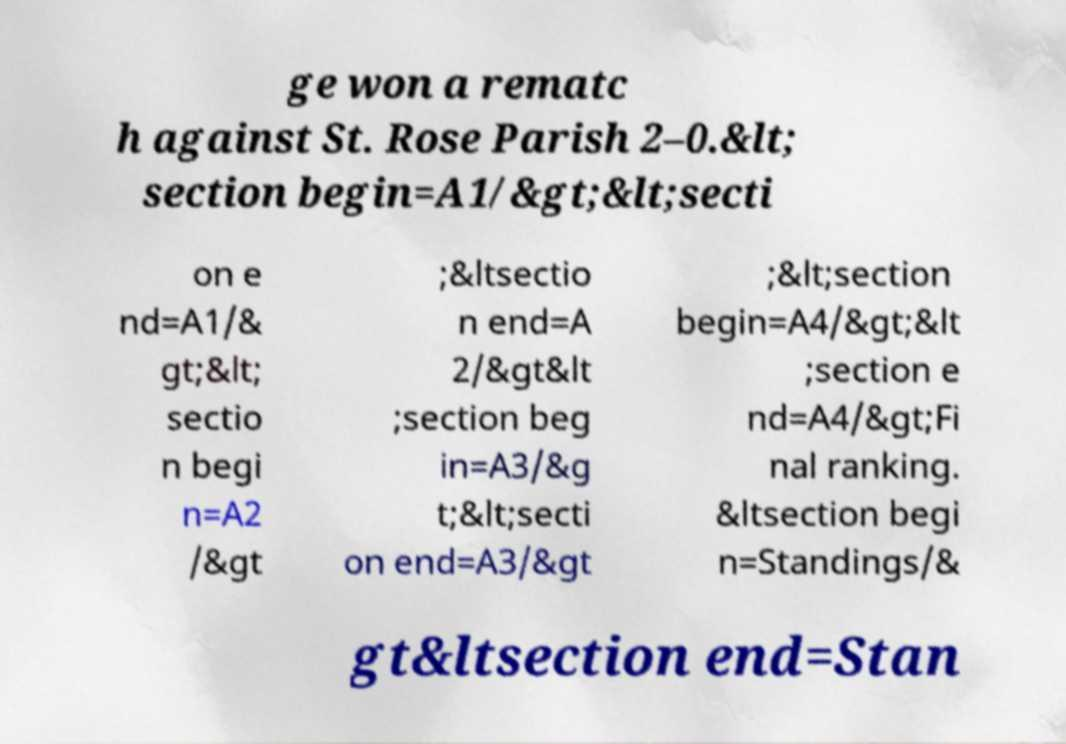Could you assist in decoding the text presented in this image and type it out clearly? ge won a rematc h against St. Rose Parish 2–0.&lt; section begin=A1/&gt;&lt;secti on e nd=A1/& gt;&lt; sectio n begi n=A2 /&gt ;&ltsectio n end=A 2/&gt&lt ;section beg in=A3/&g t;&lt;secti on end=A3/&gt ;&lt;section begin=A4/&gt;&lt ;section e nd=A4/&gt;Fi nal ranking. &ltsection begi n=Standings/& gt&ltsection end=Stan 